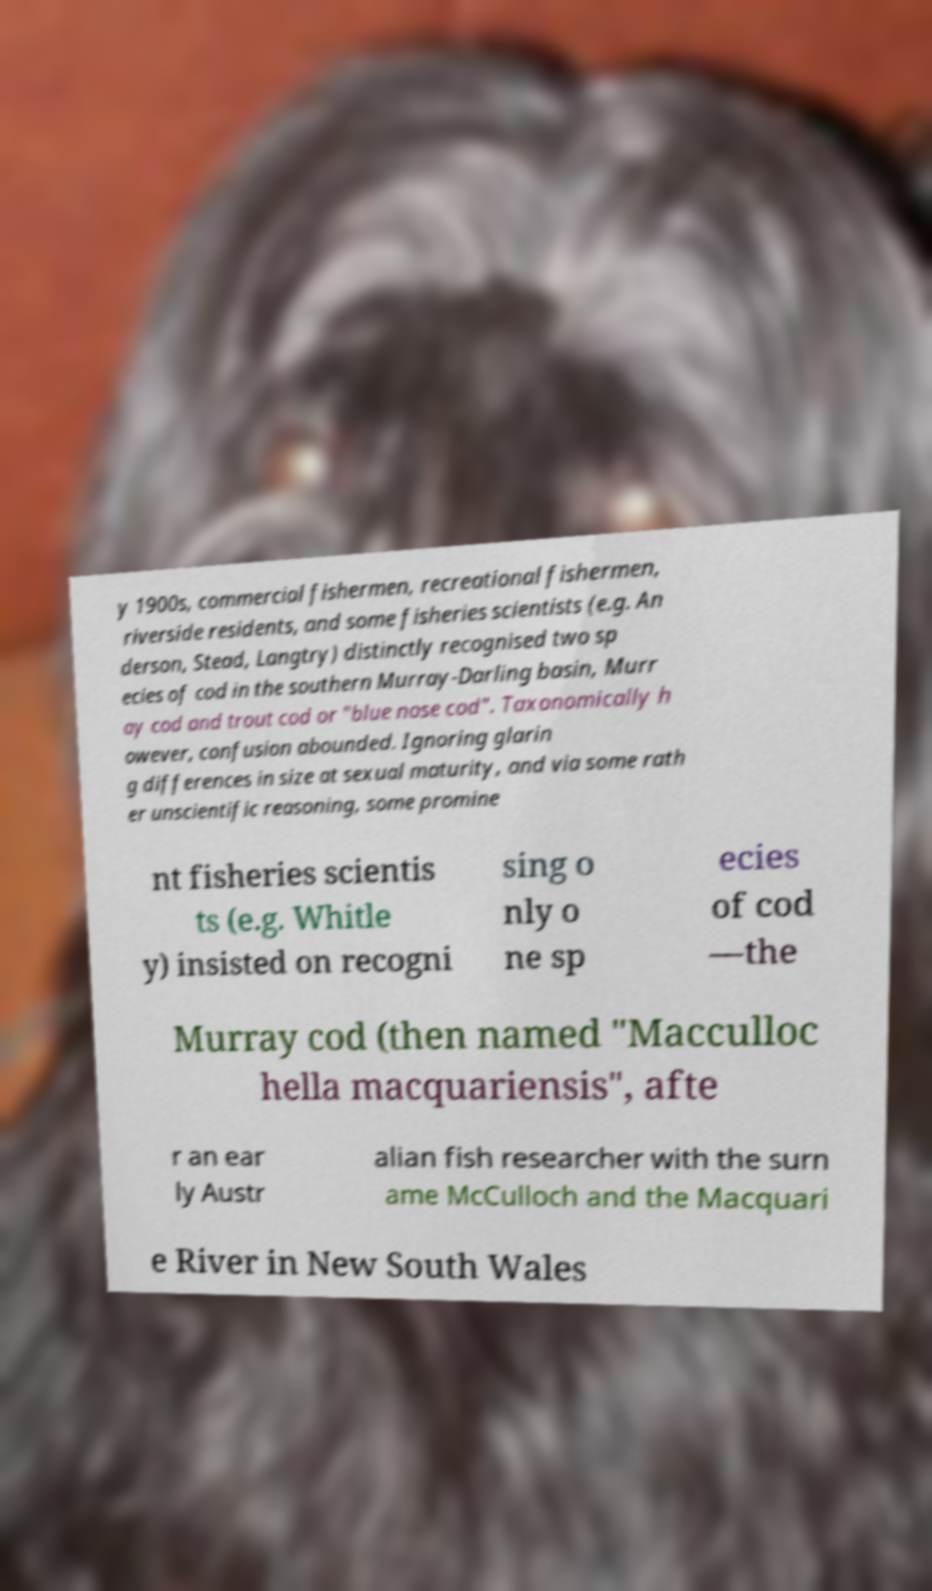Please read and relay the text visible in this image. What does it say? y 1900s, commercial fishermen, recreational fishermen, riverside residents, and some fisheries scientists (e.g. An derson, Stead, Langtry) distinctly recognised two sp ecies of cod in the southern Murray-Darling basin, Murr ay cod and trout cod or "blue nose cod". Taxonomically h owever, confusion abounded. Ignoring glarin g differences in size at sexual maturity, and via some rath er unscientific reasoning, some promine nt fisheries scientis ts (e.g. Whitle y) insisted on recogni sing o nly o ne sp ecies of cod —the Murray cod (then named "Macculloc hella macquariensis", afte r an ear ly Austr alian fish researcher with the surn ame McCulloch and the Macquari e River in New South Wales 